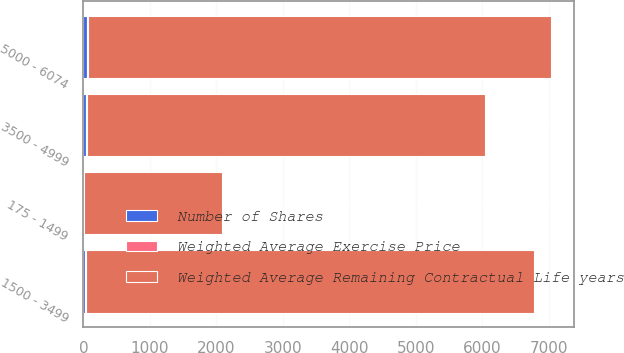Convert chart to OTSL. <chart><loc_0><loc_0><loc_500><loc_500><stacked_bar_chart><ecel><fcel>175 - 1499<fcel>1500 - 3499<fcel>3500 - 4999<fcel>5000 - 6074<nl><fcel>Weighted Average Remaining Contractual Life years<fcel>2064<fcel>6737<fcel>5992<fcel>6967<nl><fcel>Weighted Average Exercise Price<fcel>3.5<fcel>6.6<fcel>8.8<fcel>9.1<nl><fcel>Number of Shares<fcel>10.44<fcel>30.73<fcel>39.96<fcel>54.86<nl></chart> 